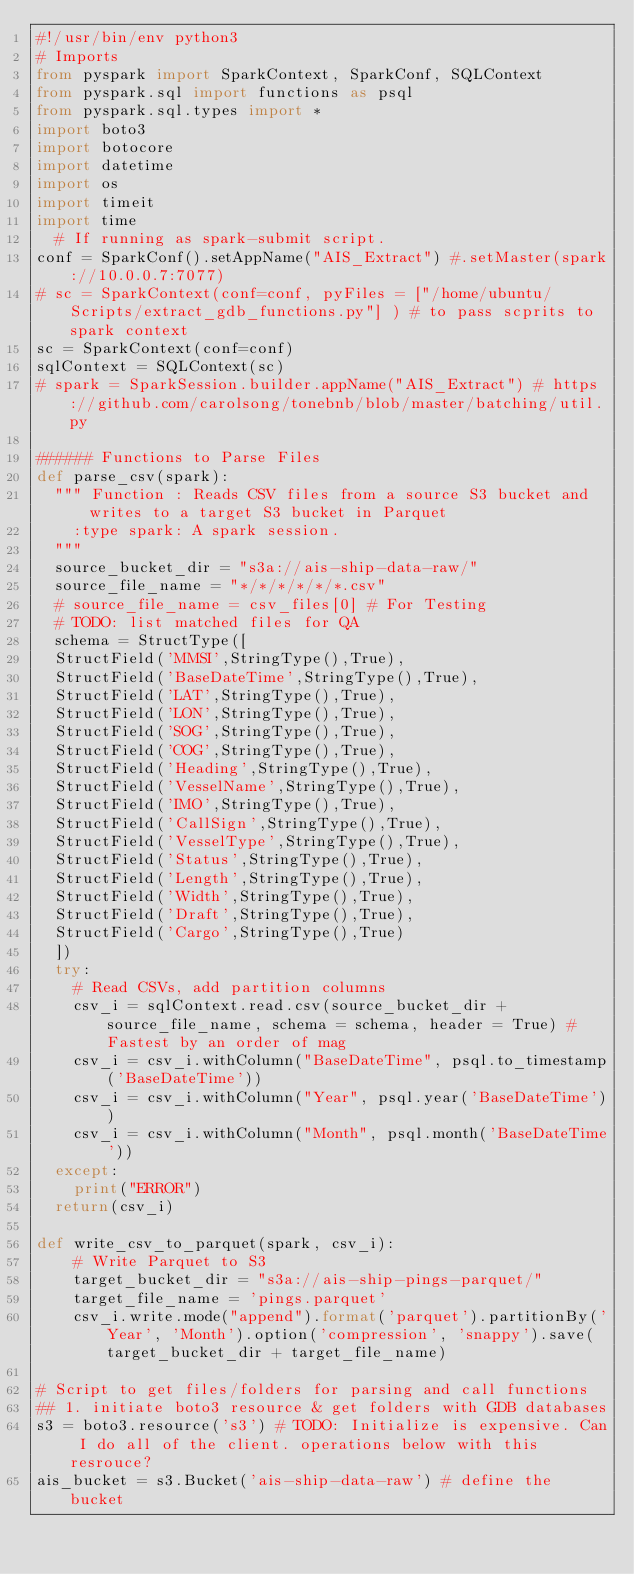<code> <loc_0><loc_0><loc_500><loc_500><_Python_>#!/usr/bin/env python3
# Imports
from pyspark import SparkContext, SparkConf, SQLContext
from pyspark.sql import functions as psql
from pyspark.sql.types import *
import boto3 
import botocore
import datetime
import os
import timeit
import time
	# If running as spark-submit script.
conf = SparkConf().setAppName("AIS_Extract") #.setMaster(spark://10.0.0.7:7077)
# sc = SparkContext(conf=conf, pyFiles = ["/home/ubuntu/Scripts/extract_gdb_functions.py"] ) # to pass scprits to spark context
sc = SparkContext(conf=conf)
sqlContext = SQLContext(sc)
# spark = SparkSession.builder.appName("AIS_Extract") # https://github.com/carolsong/tonebnb/blob/master/batching/util.py

###### Functions to Parse Files
def parse_csv(spark):
	""" Function : Reads CSV files from a source S3 bucket and writes to a target S3 bucket in Parquet
		:type spark: A spark session.
	"""
	source_bucket_dir = "s3a://ais-ship-data-raw/"
	source_file_name = "*/*/*/*/*/*.csv"
	# source_file_name = csv_files[0] # For Testing
	# TODO: list matched files for QA
	schema = StructType([
	StructField('MMSI',StringType(),True),
	StructField('BaseDateTime',StringType(),True),
	StructField('LAT',StringType(),True),
	StructField('LON',StringType(),True),
	StructField('SOG',StringType(),True),
	StructField('COG',StringType(),True),
	StructField('Heading',StringType(),True),
	StructField('VesselName',StringType(),True),
	StructField('IMO',StringType(),True),
	StructField('CallSign',StringType(),True),
	StructField('VesselType',StringType(),True),
	StructField('Status',StringType(),True),
	StructField('Length',StringType(),True),
	StructField('Width',StringType(),True),
	StructField('Draft',StringType(),True),
	StructField('Cargo',StringType(),True)
	])
	try:
		# Read CSVs, add partition columns
		csv_i = sqlContext.read.csv(source_bucket_dir + source_file_name, schema = schema, header = True) # Fastest by an order of mag
		csv_i = csv_i.withColumn("BaseDateTime", psql.to_timestamp('BaseDateTime'))
		csv_i = csv_i.withColumn("Year", psql.year('BaseDateTime'))
		csv_i = csv_i.withColumn("Month", psql.month('BaseDateTime'))
	except:
		print("ERROR")
	return(csv_i)

def write_csv_to_parquet(spark, csv_i):
		# Write Parquet to S3 
		target_bucket_dir = "s3a://ais-ship-pings-parquet/"
		target_file_name = 'pings.parquet'
		csv_i.write.mode("append").format('parquet').partitionBy('Year', 'Month').option('compression', 'snappy').save(target_bucket_dir + target_file_name)

# Script to get files/folders for parsing and call functions
## 1. initiate boto3 resource & get folders with GDB databases
s3 = boto3.resource('s3') # TODO: Initialize is expensive. Can I do all of the client. operations below with this resrouce?
ais_bucket = s3.Bucket('ais-ship-data-raw') # define the bucket</code> 